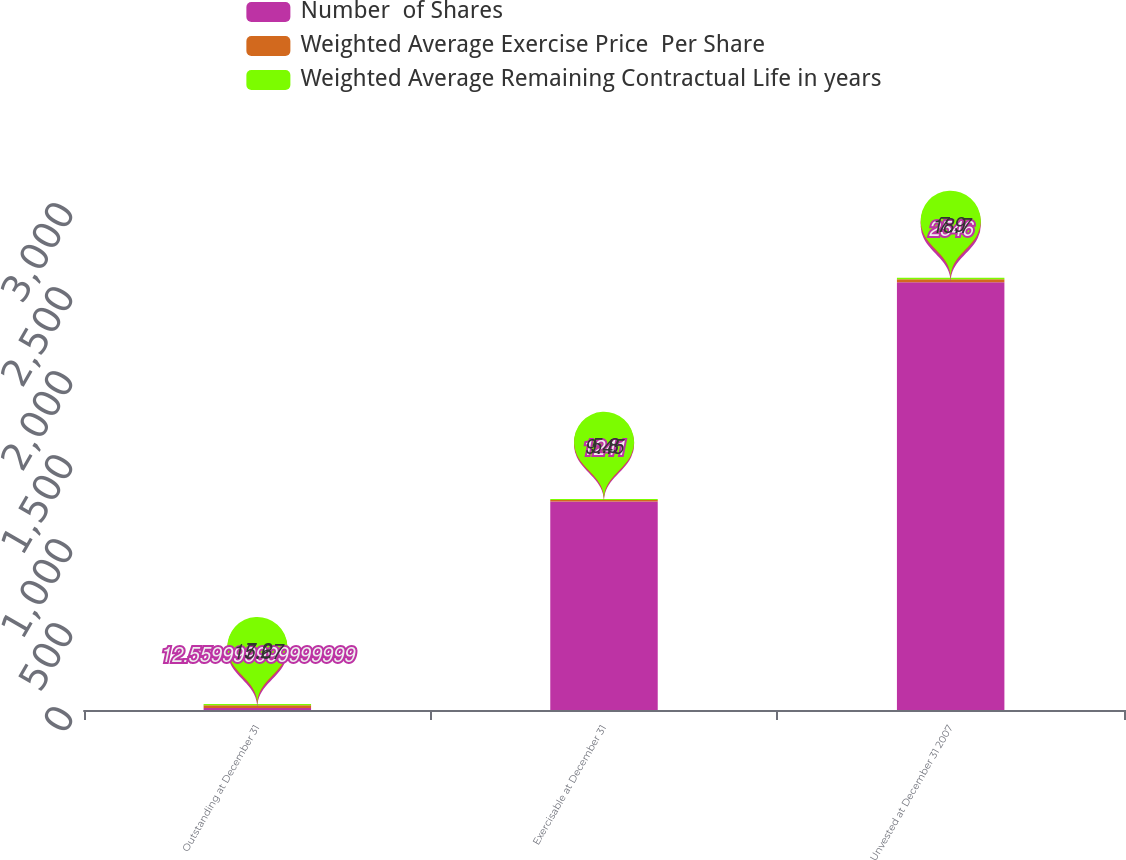<chart> <loc_0><loc_0><loc_500><loc_500><stacked_bar_chart><ecel><fcel>Outstanding at December 31<fcel>Exercisable at December 31<fcel>Unvested at December 31 2007<nl><fcel>Number  of Shares<fcel>12.56<fcel>1241<fcel>2546<nl><fcel>Weighted Average Exercise Price  Per Share<fcel>15.67<fcel>9.45<fcel>18.7<nl><fcel>Weighted Average Remaining Contractual Life in years<fcel>7.2<fcel>5.8<fcel>7.9<nl></chart> 